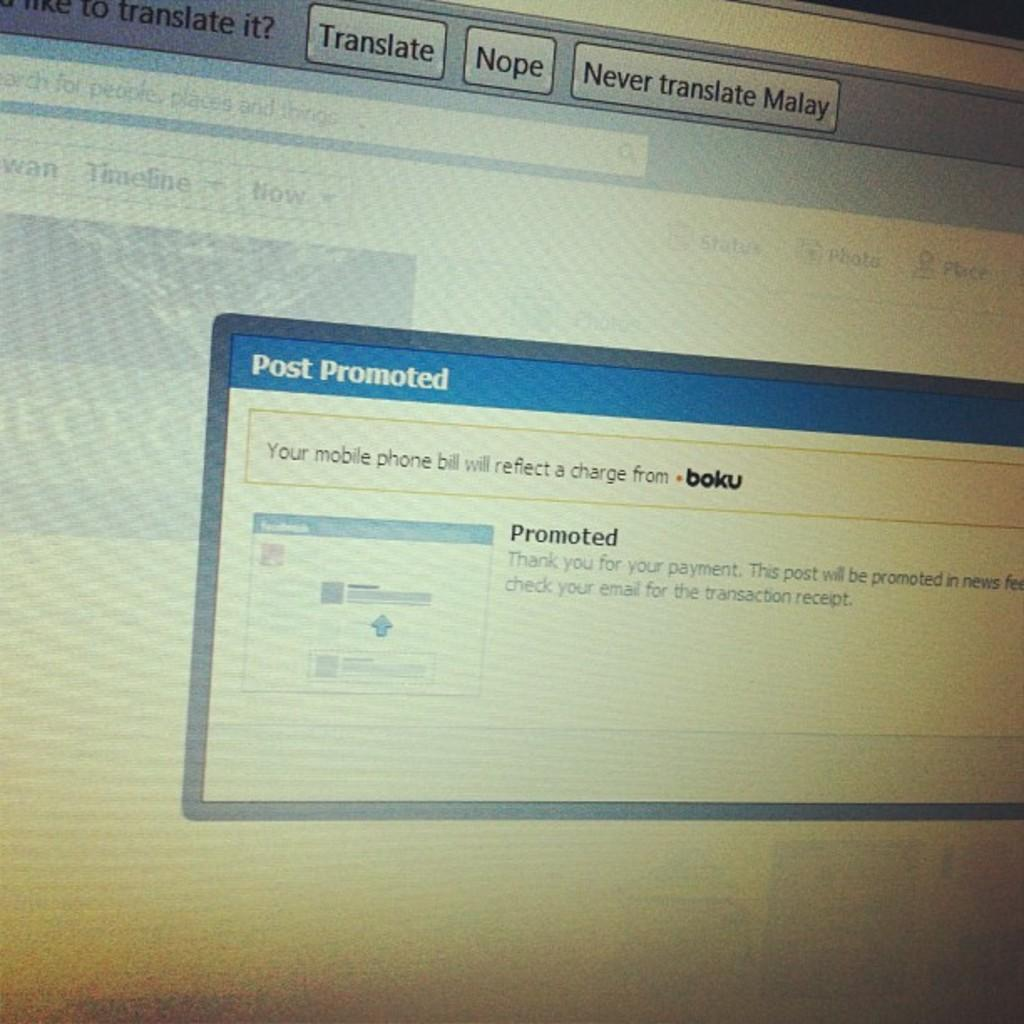What is the main object in the image? There is a screen in the image. What type of sweater is being worn by the person on the screen? There is no person visible on the screen in the image, so it is not possible to determine what type of sweater they might be wearing. 